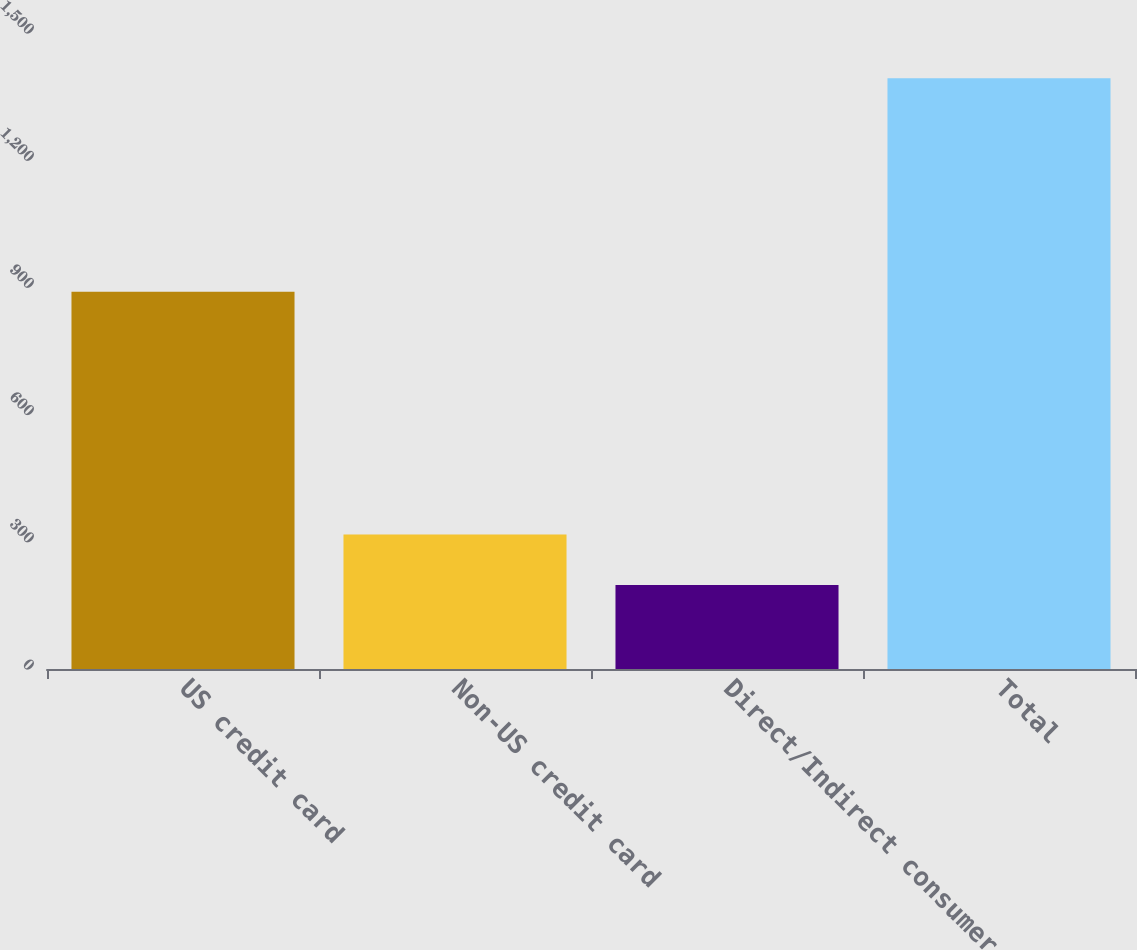<chart> <loc_0><loc_0><loc_500><loc_500><bar_chart><fcel>US credit card<fcel>Non-US credit card<fcel>Direct/Indirect consumer<fcel>Total<nl><fcel>890<fcel>317.5<fcel>198<fcel>1393<nl></chart> 